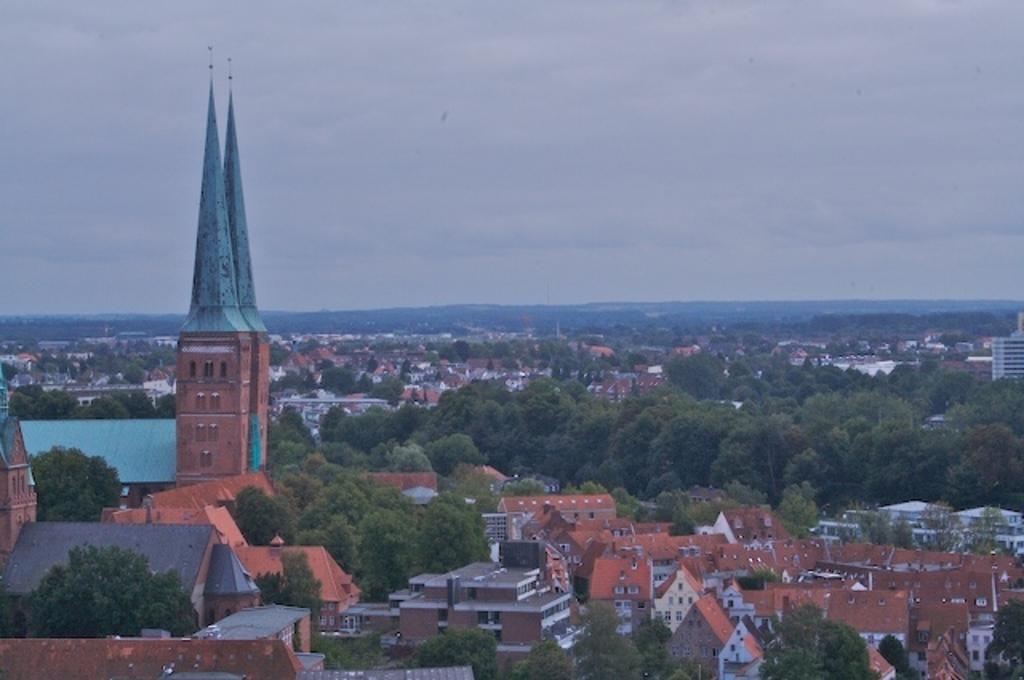What type of structures are located at the bottom of the image? There are houses at the bottom of the image. What part of the houses can be seen in the image? Roofs are visible in the image. What architectural features are present in the houses? Windows are present in the image. What can be seen in the background of the image? There are trees and buildings visible in the background of the image. What is visible in the sky in the background of the image? Clouds are present in the sky in the background of the image. What type of hobbies are the people in jail engaging in within the image? There is no jail or people engaging in hobbies present in the image. What type of fruit is being used to make quince jelly in the image? There is no quince or jelly-making activity present in the image. 